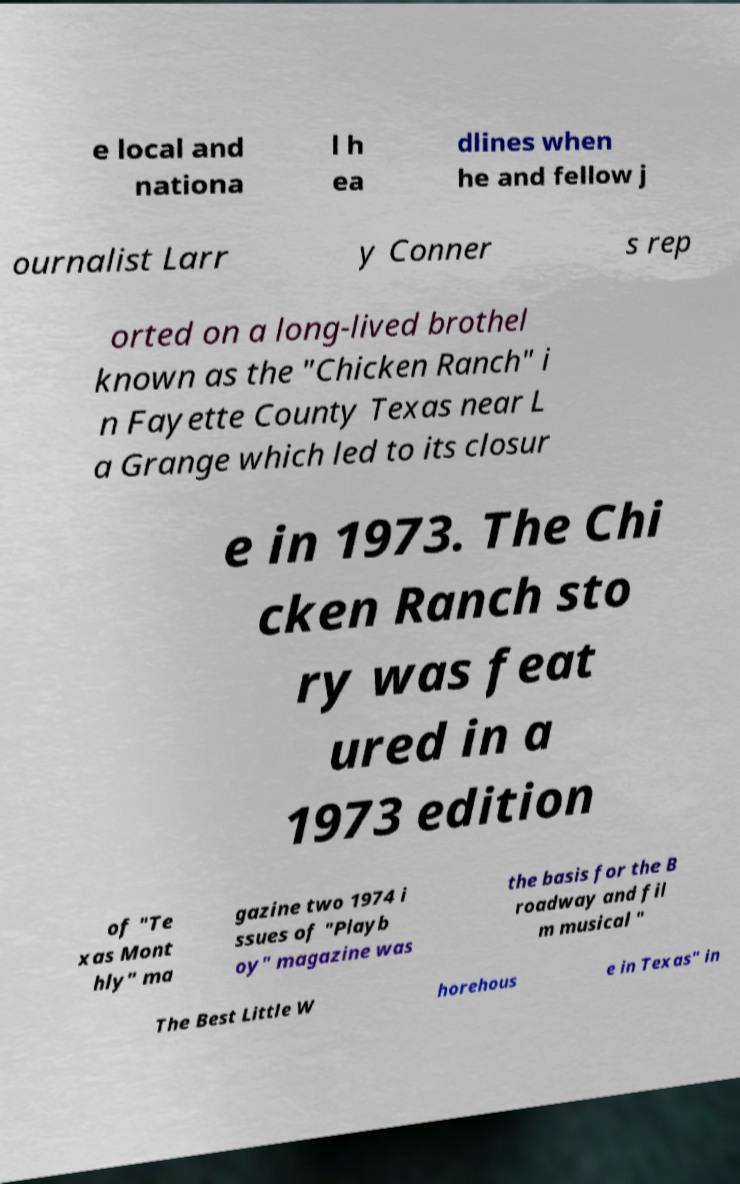Could you extract and type out the text from this image? e local and nationa l h ea dlines when he and fellow j ournalist Larr y Conner s rep orted on a long-lived brothel known as the "Chicken Ranch" i n Fayette County Texas near L a Grange which led to its closur e in 1973. The Chi cken Ranch sto ry was feat ured in a 1973 edition of "Te xas Mont hly" ma gazine two 1974 i ssues of "Playb oy" magazine was the basis for the B roadway and fil m musical " The Best Little W horehous e in Texas" in 